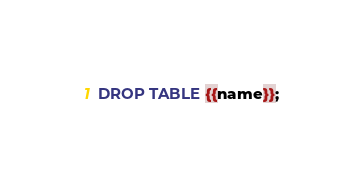Convert code to text. <code><loc_0><loc_0><loc_500><loc_500><_SQL_>DROP TABLE {{name}};
</code> 